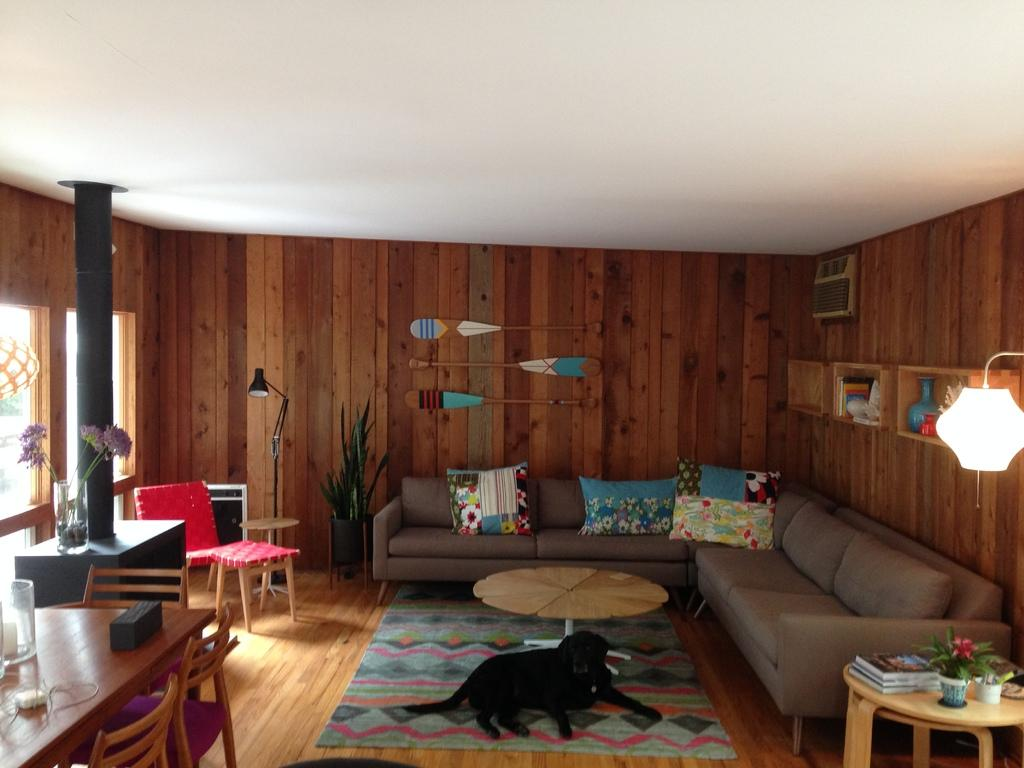What type of furniture is present in the image? There are sofas, tables, and chairs in the image. What can be found on the sofas? There are cushions on the sofas. What other objects can be seen in the image? There is a dog, a lamp, a plant, and books on a table in the image. What type of badge is the dog wearing in the image? There is no badge present on the dog in the image. What is the dog doing with its knee in the image? There is no mention of the dog's knee in the image, and the dog is not performing any specific action. 